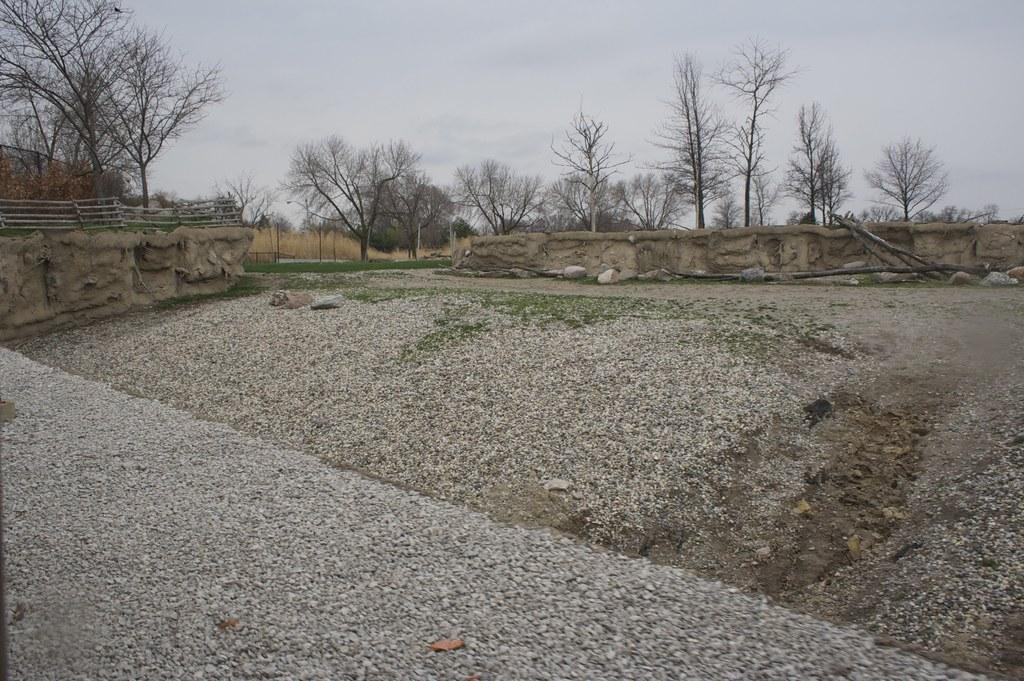What type of natural elements can be seen in the image? There are stones, trees, and the sky visible in the image. What man-made structures are present in the image? There are walls and fencing in the image. What is visible in the background of the image? The sky is visible in the background of the image. What type of bait is being used by the fish in the image? There are no fish or bait present in the image; it features stones, walls, trees, fencing, and the sky. What type of sponge is being used to clean the walls in the image? There is no sponge visible in the image; it only shows stones, walls, trees, fencing, and the sky. 